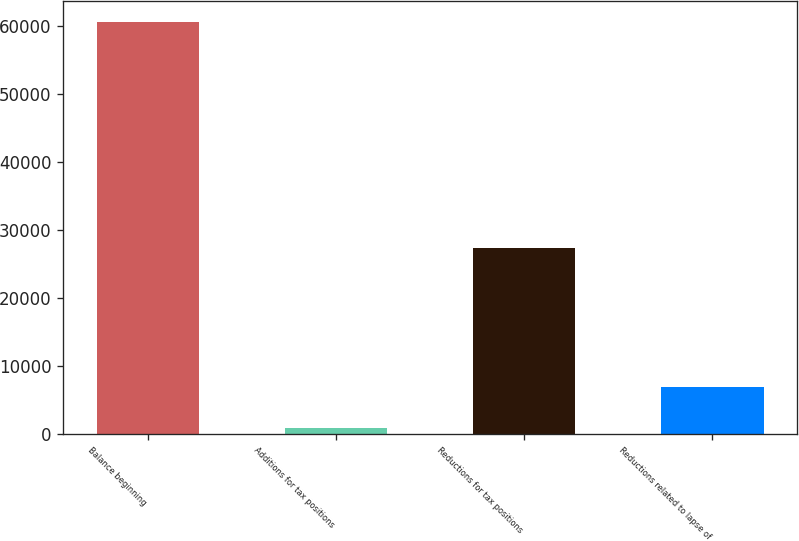Convert chart. <chart><loc_0><loc_0><loc_500><loc_500><bar_chart><fcel>Balance beginning<fcel>Additions for tax positions<fcel>Reductions for tax positions<fcel>Reductions related to lapse of<nl><fcel>60538<fcel>914<fcel>27312<fcel>6876.4<nl></chart> 